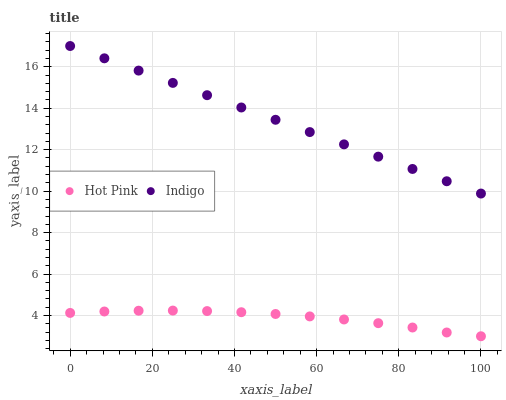Does Hot Pink have the minimum area under the curve?
Answer yes or no. Yes. Does Indigo have the maximum area under the curve?
Answer yes or no. Yes. Does Indigo have the minimum area under the curve?
Answer yes or no. No. Is Indigo the smoothest?
Answer yes or no. Yes. Is Hot Pink the roughest?
Answer yes or no. Yes. Is Indigo the roughest?
Answer yes or no. No. Does Hot Pink have the lowest value?
Answer yes or no. Yes. Does Indigo have the lowest value?
Answer yes or no. No. Does Indigo have the highest value?
Answer yes or no. Yes. Is Hot Pink less than Indigo?
Answer yes or no. Yes. Is Indigo greater than Hot Pink?
Answer yes or no. Yes. Does Hot Pink intersect Indigo?
Answer yes or no. No. 